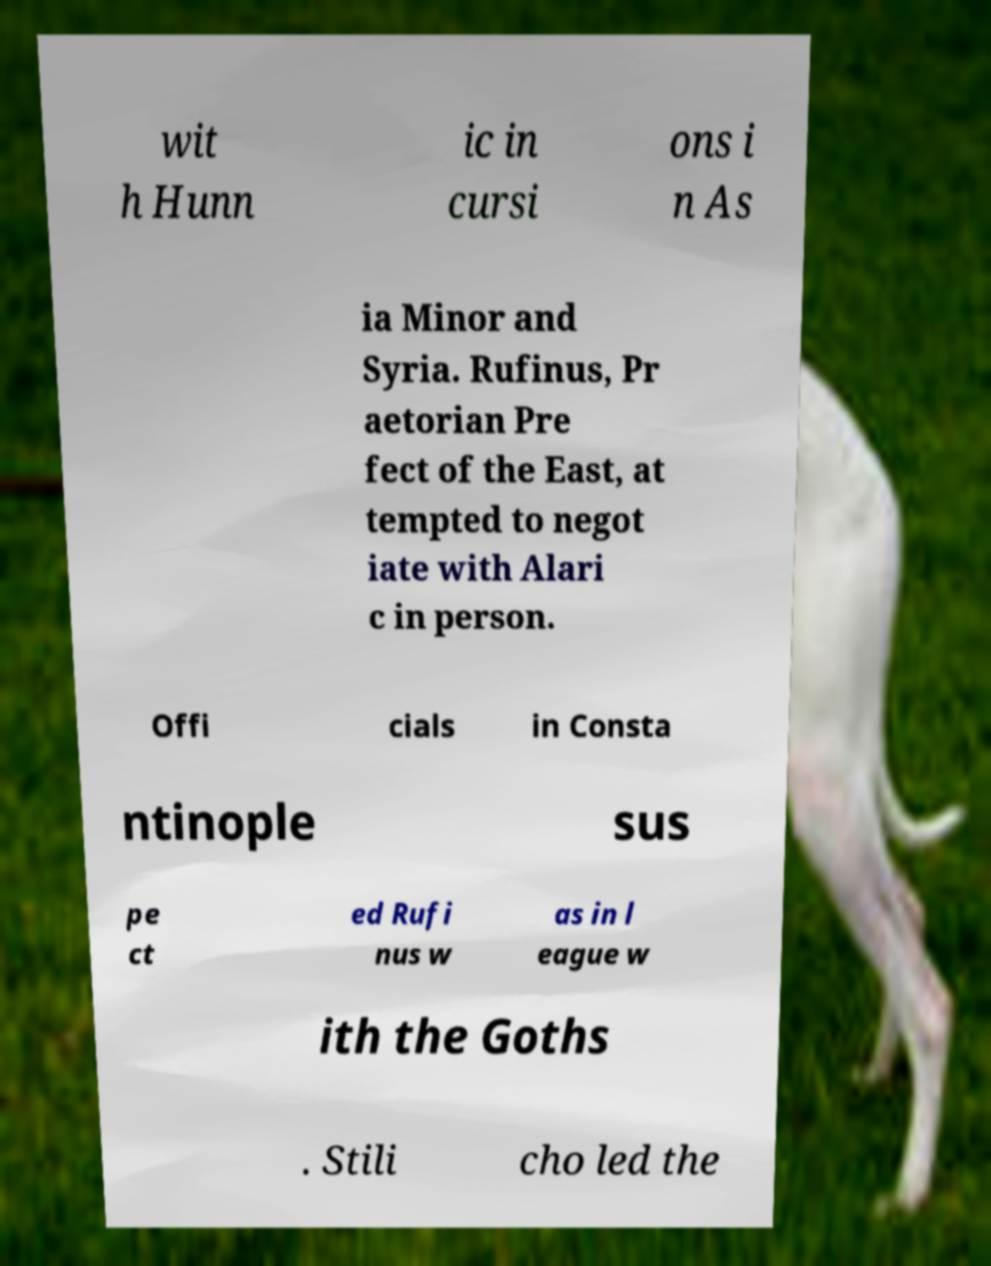Could you assist in decoding the text presented in this image and type it out clearly? wit h Hunn ic in cursi ons i n As ia Minor and Syria. Rufinus, Pr aetorian Pre fect of the East, at tempted to negot iate with Alari c in person. Offi cials in Consta ntinople sus pe ct ed Rufi nus w as in l eague w ith the Goths . Stili cho led the 